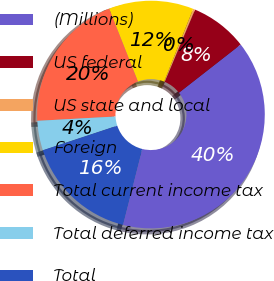Convert chart. <chart><loc_0><loc_0><loc_500><loc_500><pie_chart><fcel>(Millions)<fcel>US federal<fcel>US state and local<fcel>Foreign<fcel>Total current income tax<fcel>Total deferred income tax<fcel>Total<nl><fcel>39.51%<fcel>8.12%<fcel>0.27%<fcel>12.04%<fcel>19.89%<fcel>4.2%<fcel>15.97%<nl></chart> 